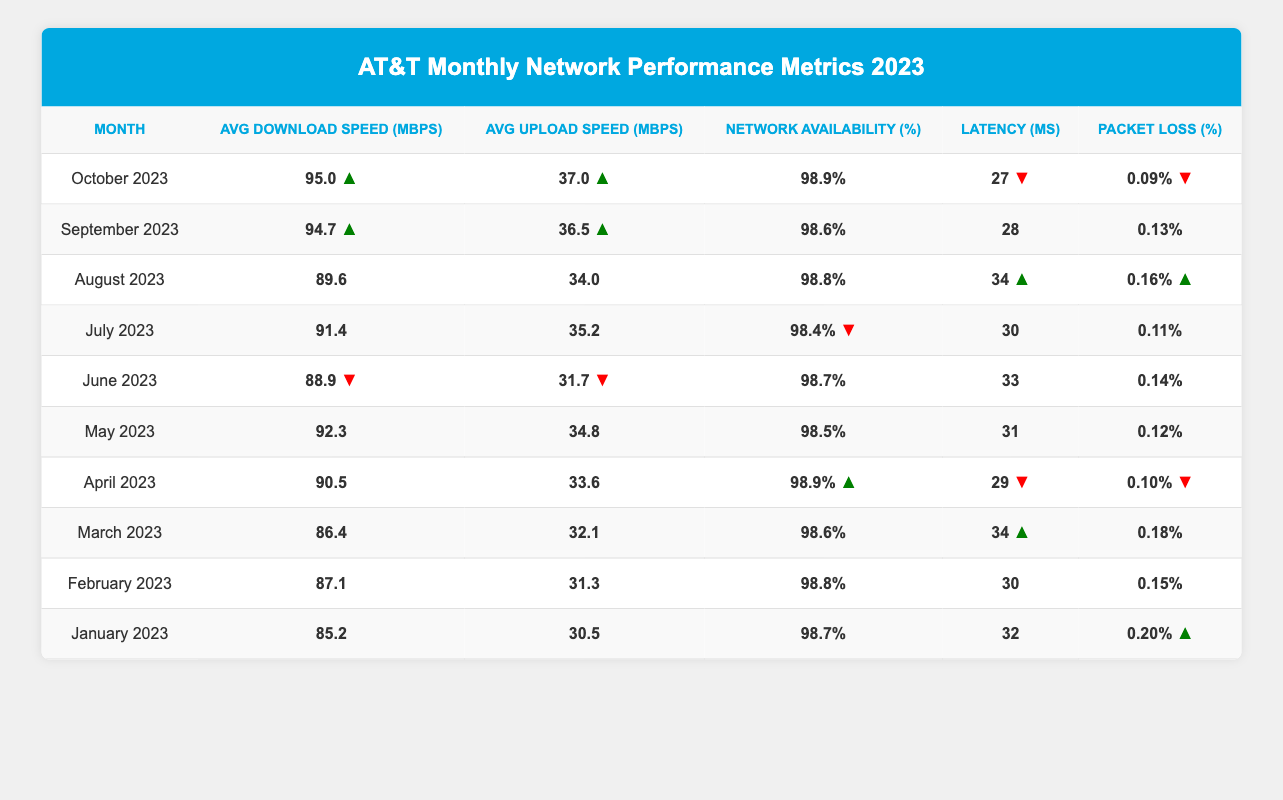What was the average download speed in October 2023? The table shows that in October 2023, the average download speed was recorded as 95.0 Mbps. Therefore, the answer is directly found in the table.
Answer: 95.0 Mbps Which month had the highest network availability percentage? By examining the table, I see that both April 2023 and October 2023 have the highest network availability percentage listed at 98.9%.
Answer: April 2023 and October 2023 What is the difference in average upload speed between May 2023 and November 2023? The table does not provide data for November 2023; thus, we focus only on May 2023, which has an average upload speed of 34.8 Mbps. Since November data isn’t available, we cannot calculate the difference.
Answer: Not applicable What was the average latency across all months? First, we gather the latency values from each month: (32 + 30 + 34 + 29 + 31 + 33 + 30 + 34 + 28 + 27) =  32.8. There are 10 months, so we divide the total by 10 to find the average latency: 320/10 = 32.0 ms.
Answer: 32.0 ms Did the packet loss percentage increase from January to March 2023? From the table, the packet loss percentage in January 2023 is 0.20%, while in March 2023 it has decreased to 0.18%. Thus, there was a decrease, not an increase.
Answer: No What was the lowest average upload speed recorded, and in which month? Reviewing the table, the lowest average upload speed is found in January 2023, which is 30.5 Mbps.
Answer: January 2023, 30.5 Mbps Was the network availability percentage consistently above 98% throughout 2023? By checking the values in the table, all months except for July (98.4%) have a network availability percentage above 98%. Therefore, it was not consistent as July fell below.
Answer: No 